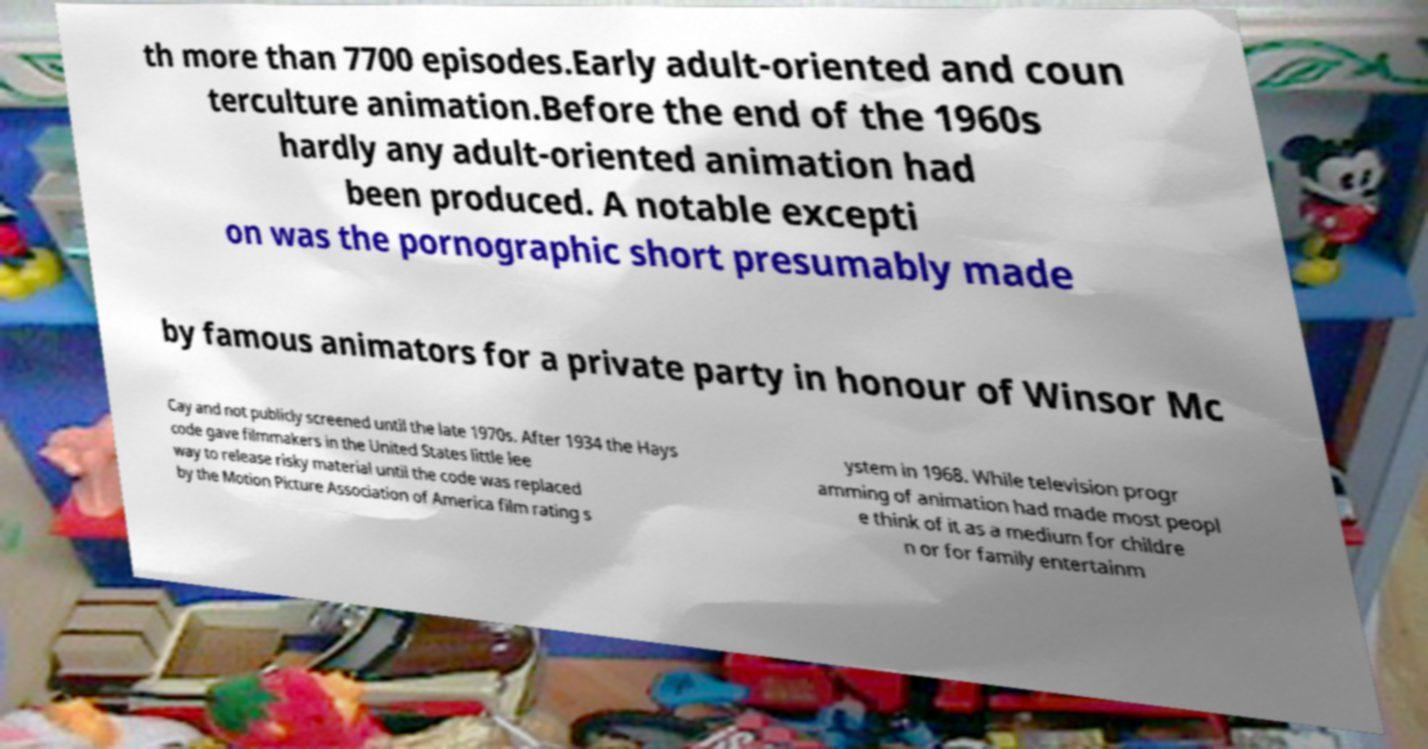Can you read and provide the text displayed in the image?This photo seems to have some interesting text. Can you extract and type it out for me? th more than 7700 episodes.Early adult-oriented and coun terculture animation.Before the end of the 1960s hardly any adult-oriented animation had been produced. A notable excepti on was the pornographic short presumably made by famous animators for a private party in honour of Winsor Mc Cay and not publicly screened until the late 1970s. After 1934 the Hays code gave filmmakers in the United States little lee way to release risky material until the code was replaced by the Motion Picture Association of America film rating s ystem in 1968. While television progr amming of animation had made most peopl e think of it as a medium for childre n or for family entertainm 